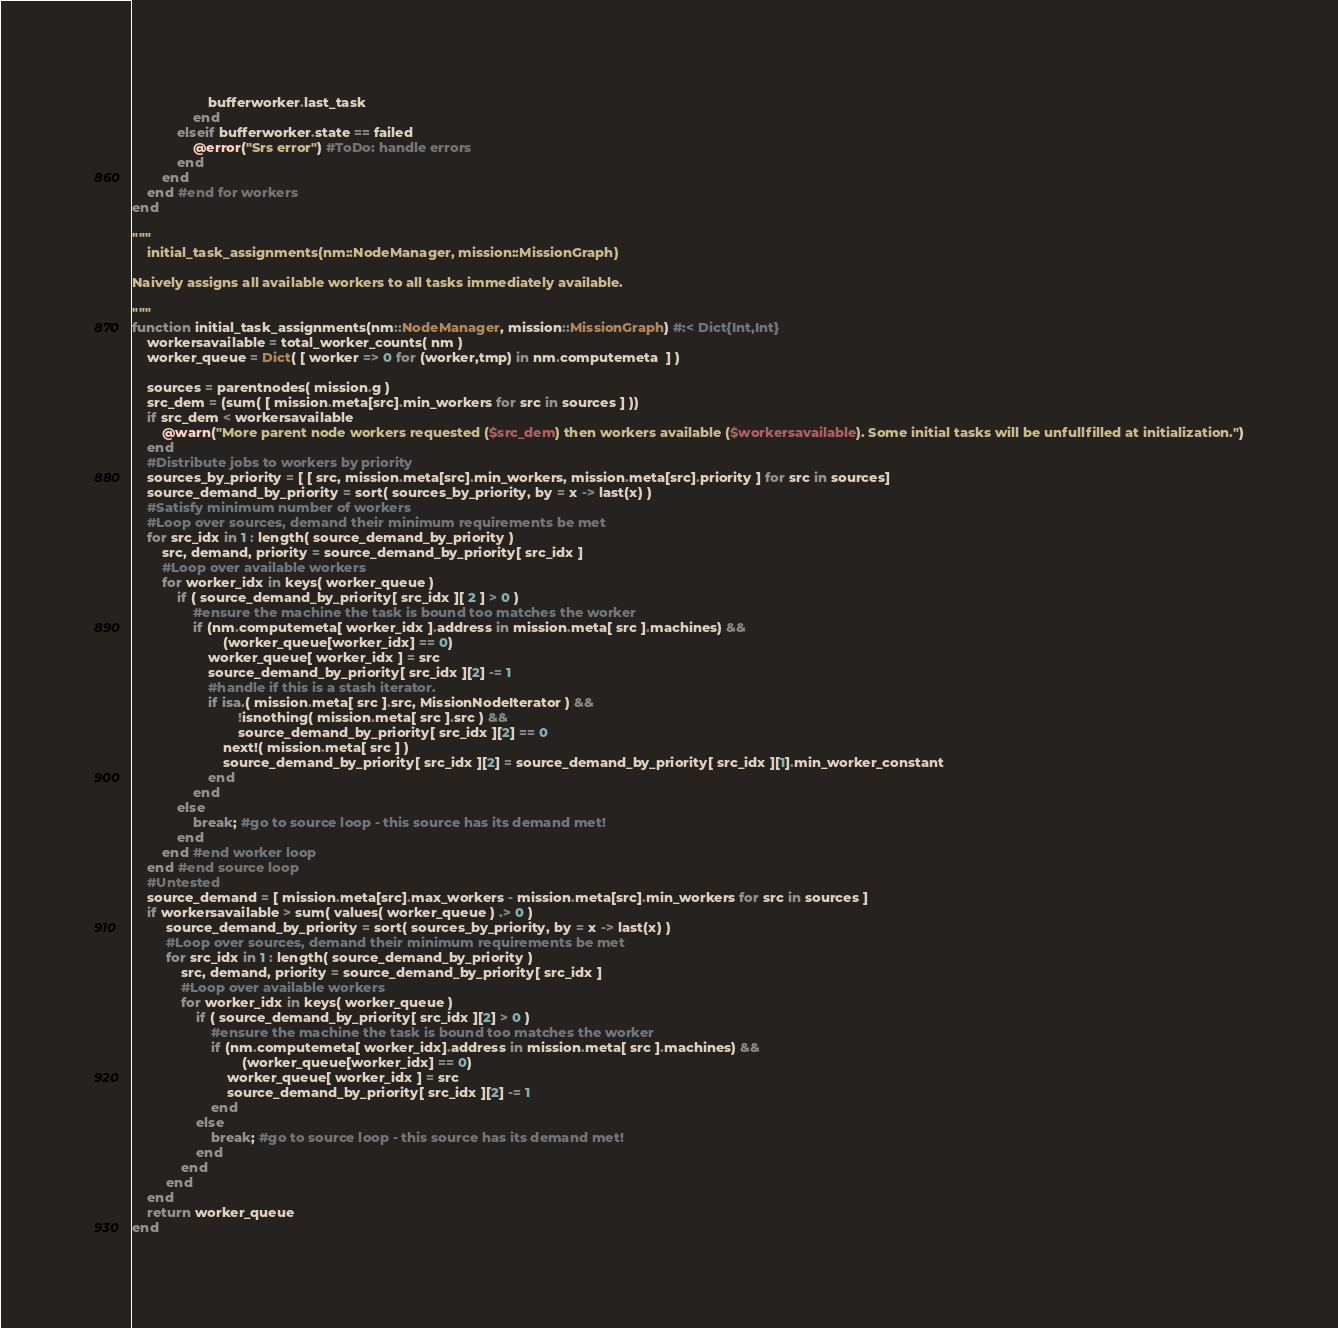Convert code to text. <code><loc_0><loc_0><loc_500><loc_500><_Julia_>                    bufferworker.last_task
                end
            elseif bufferworker.state == failed
                @error("Srs error") #ToDo: handle errors
            end
        end
    end #end for workers
end

"""
    initial_task_assignments(nm::NodeManager, mission::MissionGraph)

Naively assigns all available workers to all tasks immediately available.

"""
function initial_task_assignments(nm::NodeManager, mission::MissionGraph) #:< Dict{Int,Int}
    workersavailable = total_worker_counts( nm )
    worker_queue = Dict( [ worker => 0 for (worker,tmp) in nm.computemeta  ] )

    sources = parentnodes( mission.g )
    src_dem = (sum( [ mission.meta[src].min_workers for src in sources ] ))
    if src_dem < workersavailable
        @warn("More parent node workers requested ($src_dem) then workers available ($workersavailable). Some initial tasks will be unfullfilled at initialization.")
    end
    #Distribute jobs to workers by priority
    sources_by_priority = [ [ src, mission.meta[src].min_workers, mission.meta[src].priority ] for src in sources]
    source_demand_by_priority = sort( sources_by_priority, by = x -> last(x) )
    #Satisfy minimum number of workers
    #Loop over sources, demand their minimum requirements be met
    for src_idx in 1 : length( source_demand_by_priority )
        src, demand, priority = source_demand_by_priority[ src_idx ]
        #Loop over available workers
        for worker_idx in keys( worker_queue )
            if ( source_demand_by_priority[ src_idx ][ 2 ] > 0 )
                #ensure the machine the task is bound too matches the worker
                if (nm.computemeta[ worker_idx ].address in mission.meta[ src ].machines) &&
                        (worker_queue[worker_idx] == 0)
                    worker_queue[ worker_idx ] = src
                    source_demand_by_priority[ src_idx ][2] -= 1
                    #handle if this is a stash iterator.
                    if isa.( mission.meta[ src ].src, MissionNodeIterator ) &&
                            !isnothing( mission.meta[ src ].src ) &&
                            source_demand_by_priority[ src_idx ][2] == 0
                        next!( mission.meta[ src ] )
                        source_demand_by_priority[ src_idx ][2] = source_demand_by_priority[ src_idx ][1].min_worker_constant
                    end
                end
            else
                break; #go to source loop - this source has its demand met!
            end
        end #end worker loop
    end #end source loop
    #Untested
    source_demand = [ mission.meta[src].max_workers - mission.meta[src].min_workers for src in sources ]
    if workersavailable > sum( values( worker_queue ) .> 0 )
         source_demand_by_priority = sort( sources_by_priority, by = x -> last(x) )
         #Loop over sources, demand their minimum requirements be met
         for src_idx in 1 : length( source_demand_by_priority )
             src, demand, priority = source_demand_by_priority[ src_idx ]
             #Loop over available workers
             for worker_idx in keys( worker_queue )
                 if ( source_demand_by_priority[ src_idx ][2] > 0 )
                     #ensure the machine the task is bound too matches the worker
                     if (nm.computemeta[ worker_idx].address in mission.meta[ src ].machines) &&
                             (worker_queue[worker_idx] == 0)
                         worker_queue[ worker_idx ] = src
                         source_demand_by_priority[ src_idx ][2] -= 1
                     end
                 else
                     break; #go to source loop - this source has its demand met!
                 end
             end
         end
    end
    return worker_queue
end
</code> 